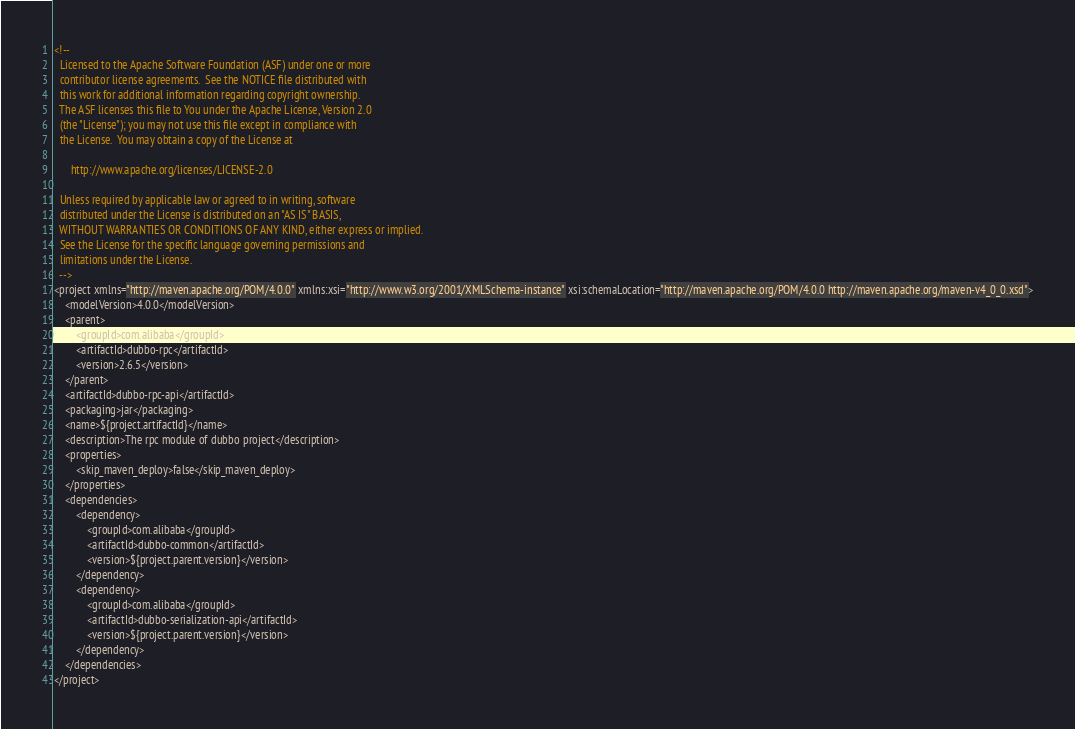<code> <loc_0><loc_0><loc_500><loc_500><_XML_><!--
  Licensed to the Apache Software Foundation (ASF) under one or more
  contributor license agreements.  See the NOTICE file distributed with
  this work for additional information regarding copyright ownership.
  The ASF licenses this file to You under the Apache License, Version 2.0
  (the "License"); you may not use this file except in compliance with
  the License.  You may obtain a copy of the License at

      http://www.apache.org/licenses/LICENSE-2.0

  Unless required by applicable law or agreed to in writing, software
  distributed under the License is distributed on an "AS IS" BASIS,
  WITHOUT WARRANTIES OR CONDITIONS OF ANY KIND, either express or implied.
  See the License for the specific language governing permissions and
  limitations under the License.
  -->
<project xmlns="http://maven.apache.org/POM/4.0.0" xmlns:xsi="http://www.w3.org/2001/XMLSchema-instance" xsi:schemaLocation="http://maven.apache.org/POM/4.0.0 http://maven.apache.org/maven-v4_0_0.xsd">
    <modelVersion>4.0.0</modelVersion>
    <parent>
        <groupId>com.alibaba</groupId>
        <artifactId>dubbo-rpc</artifactId>
        <version>2.6.5</version>
    </parent>
    <artifactId>dubbo-rpc-api</artifactId>
    <packaging>jar</packaging>
    <name>${project.artifactId}</name>
    <description>The rpc module of dubbo project</description>
    <properties>
        <skip_maven_deploy>false</skip_maven_deploy>
    </properties>
    <dependencies>
        <dependency>
            <groupId>com.alibaba</groupId>
            <artifactId>dubbo-common</artifactId>
            <version>${project.parent.version}</version>
        </dependency>
        <dependency>
            <groupId>com.alibaba</groupId>
            <artifactId>dubbo-serialization-api</artifactId>
            <version>${project.parent.version}</version>
        </dependency>
    </dependencies>
</project></code> 